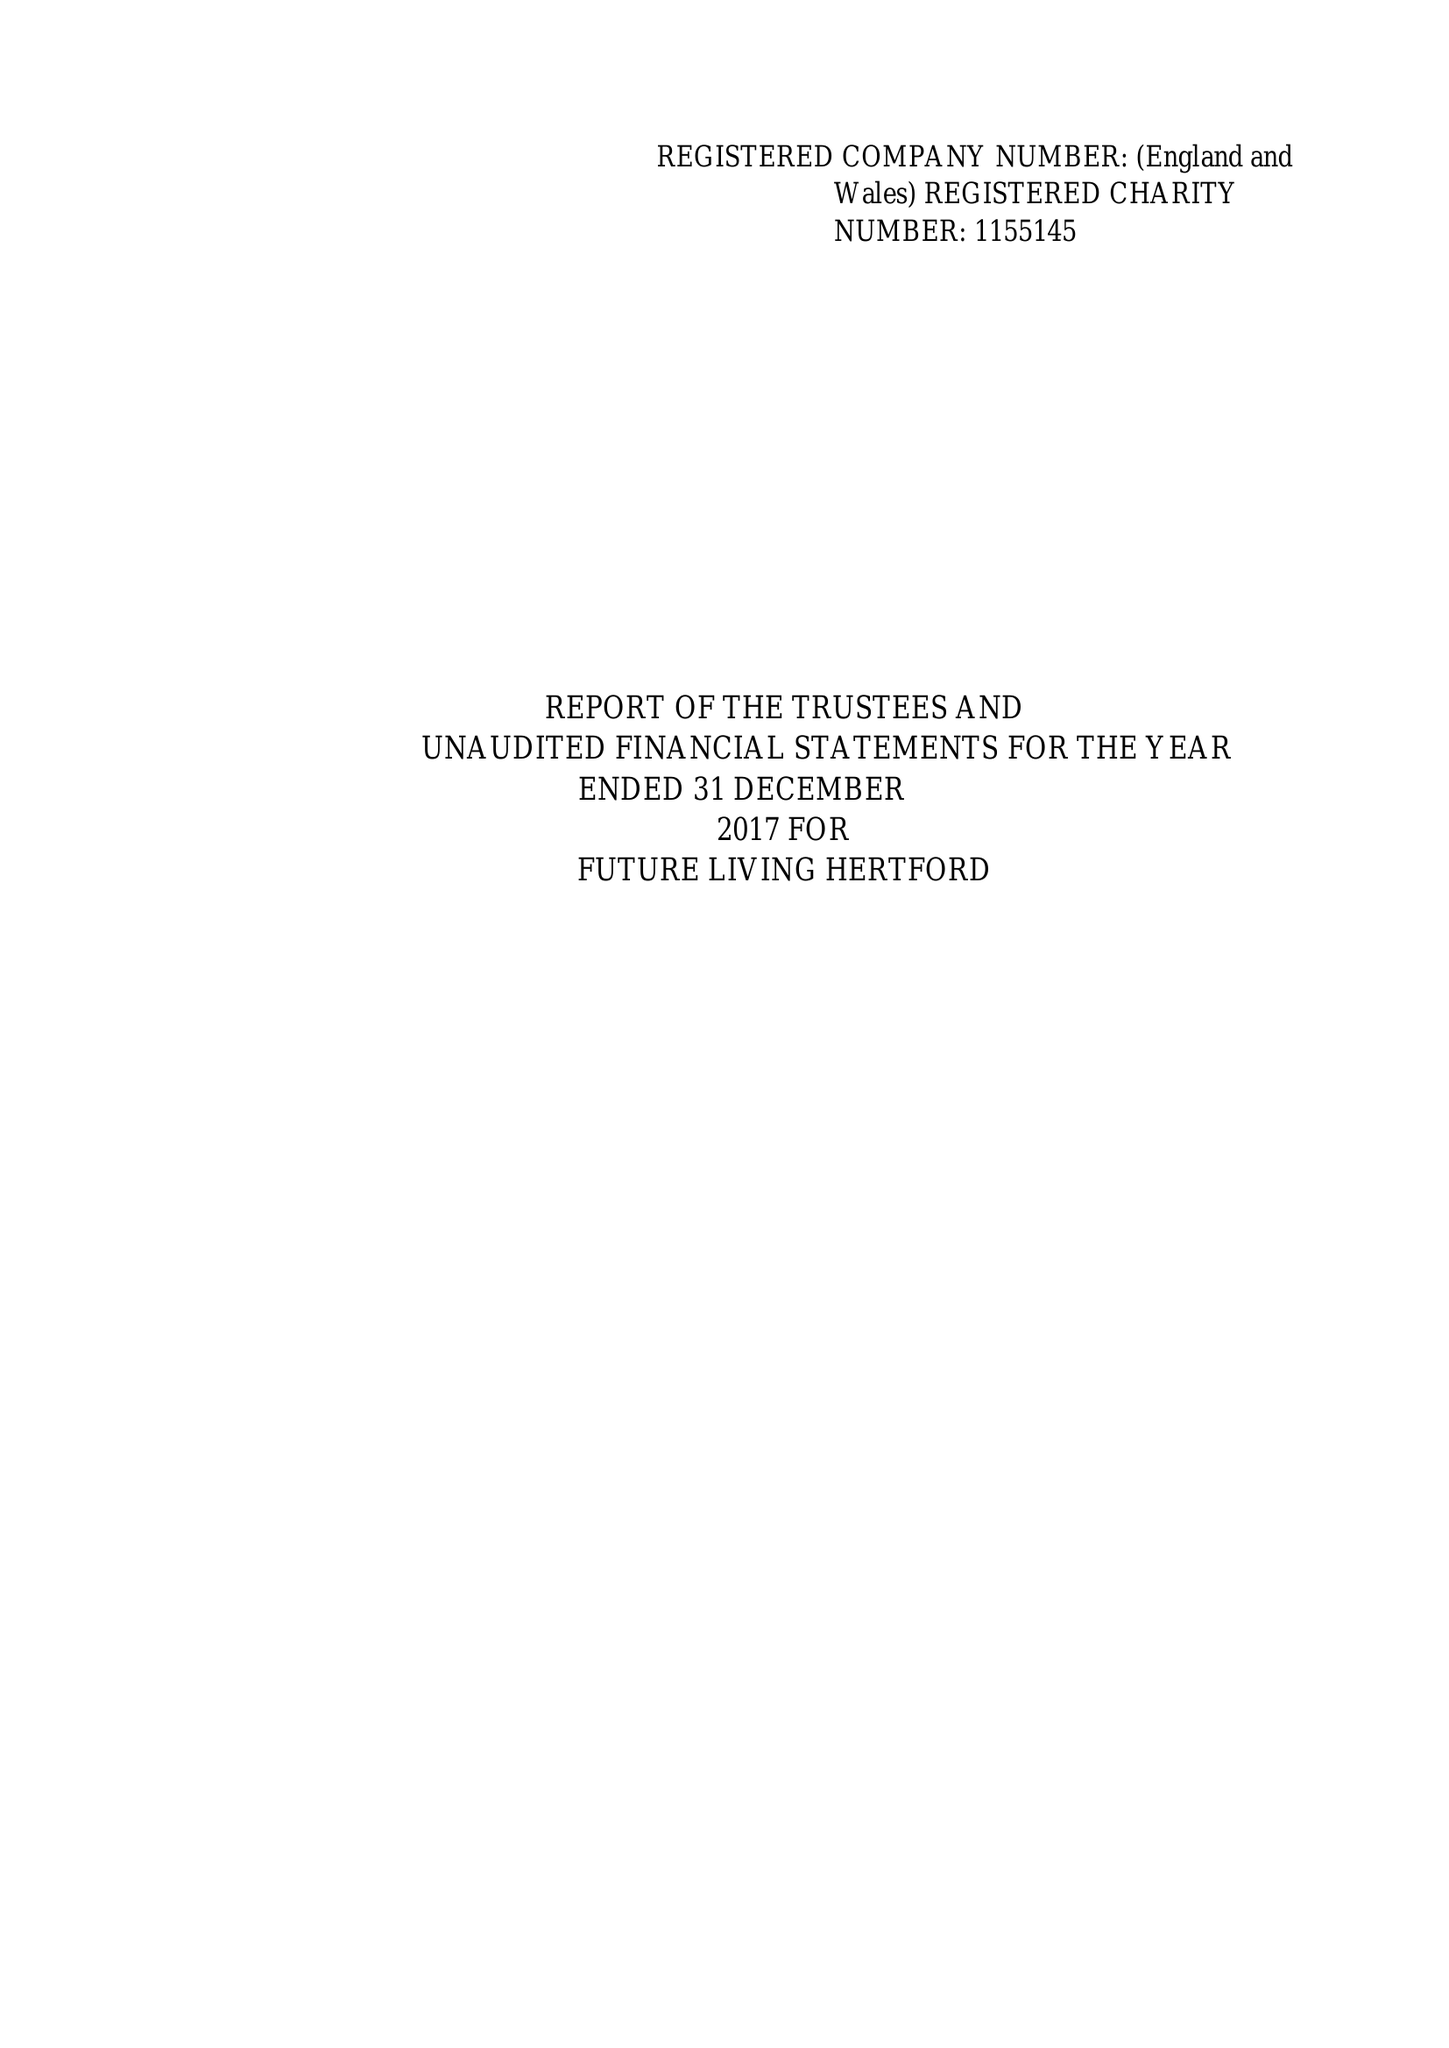What is the value for the address__street_line?
Answer the question using a single word or phrase. 43 COWBRIDGE 